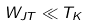Convert formula to latex. <formula><loc_0><loc_0><loc_500><loc_500>W _ { J T } \ll T _ { K }</formula> 